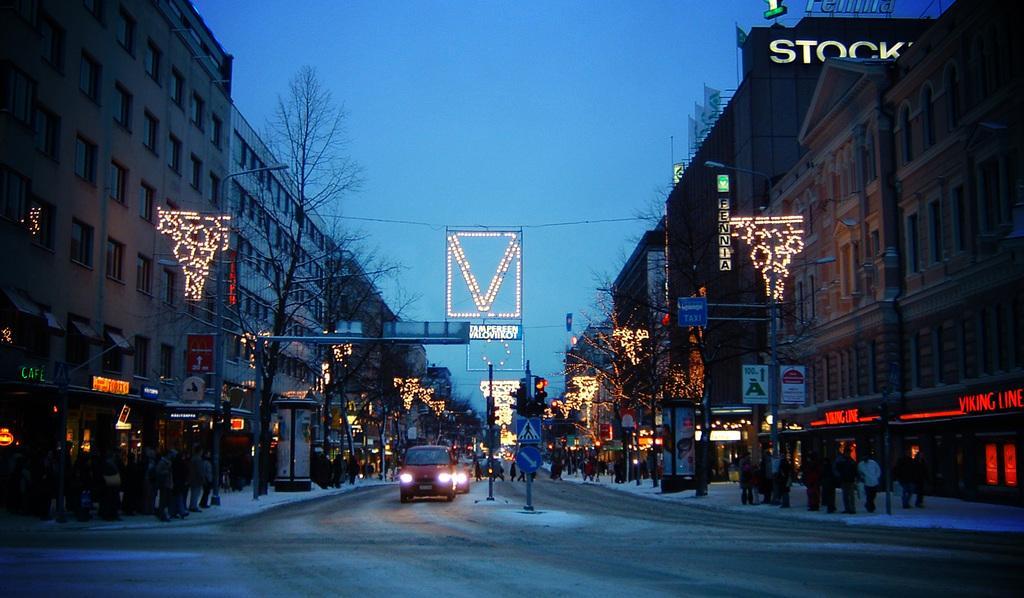Please provide a concise description of this image. In the middle we can see vehicles on the road and there is snow on the road. On the left and right side we can see few persons are standing on the footpath. In the background there are trees, buildings, windows, decorative lights, bare trees, light poles, traffic signal poles, flags on the buildings, name boards on the walls and sky. 